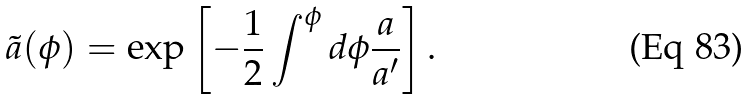<formula> <loc_0><loc_0><loc_500><loc_500>\tilde { a } ( \phi ) = \exp \left [ - \frac { 1 } { 2 } \int ^ { \phi } d \phi \frac { a } { a ^ { \prime } } \right ] .</formula> 